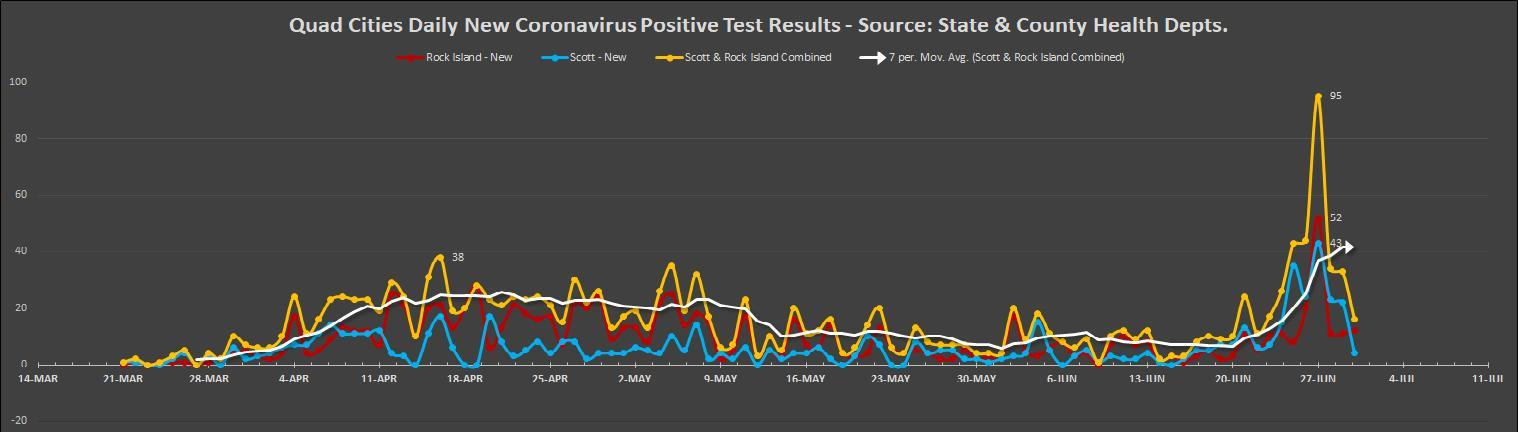Which color is used to represent Rock Island New-blue, yellow, red or white?
Answer the question with a short phrase. red Which color is used to represent Scott -New-blue, yellow, red or white? blue 